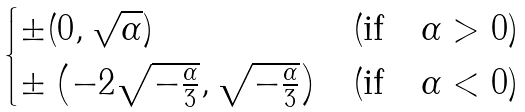Convert formula to latex. <formula><loc_0><loc_0><loc_500><loc_500>\begin{cases} \pm ( 0 , \sqrt { \alpha } ) & ( \text {if} \quad \alpha > 0 ) \\ \pm \left ( - 2 \sqrt { - \frac { \alpha } { 3 } } , \sqrt { - \frac { \alpha } { 3 } } \right ) & ( \text {if} \quad \alpha < 0 ) \end{cases}</formula> 